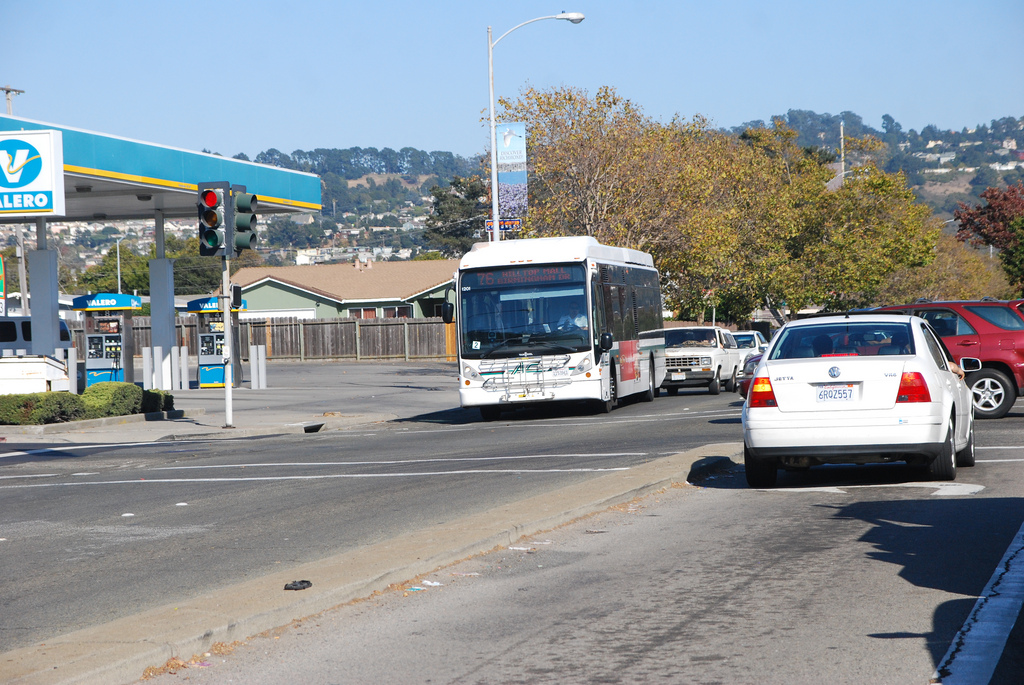Is the bus to the right or to the left of the fence on the left? The white bus is to the right of the wooden fence that lines the left side of the image. 